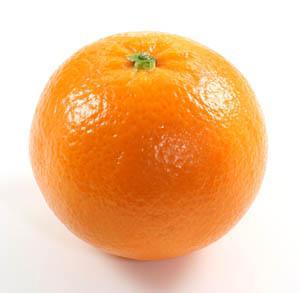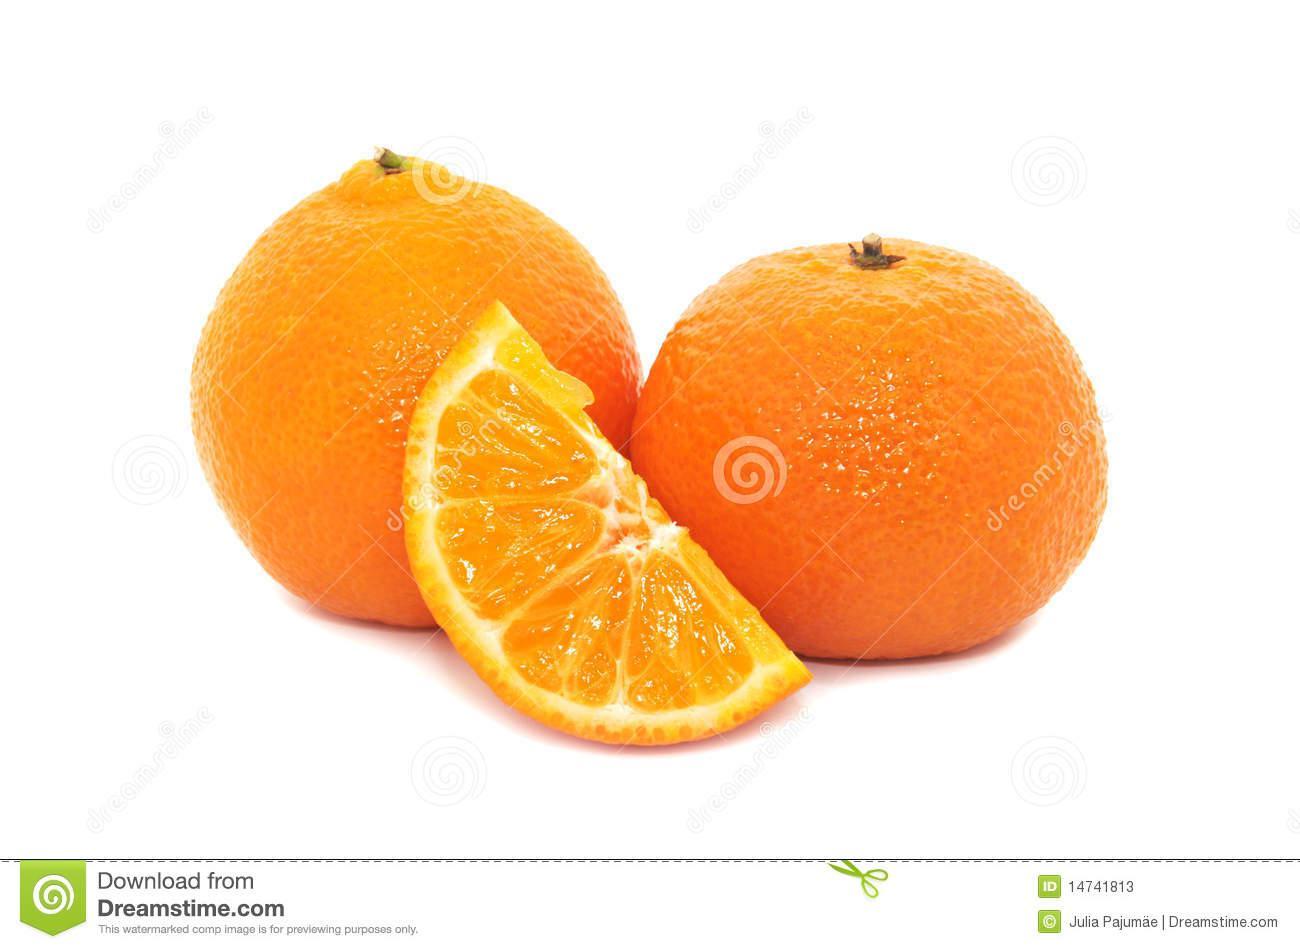The first image is the image on the left, the second image is the image on the right. Analyze the images presented: Is the assertion "An orange has been sliced into halves" valid? Answer yes or no. No. 